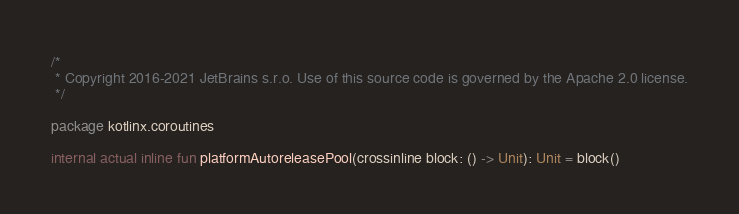<code> <loc_0><loc_0><loc_500><loc_500><_Kotlin_>/*
 * Copyright 2016-2021 JetBrains s.r.o. Use of this source code is governed by the Apache 2.0 license.
 */

package kotlinx.coroutines

internal actual inline fun platformAutoreleasePool(crossinline block: () -> Unit): Unit = block()
</code> 